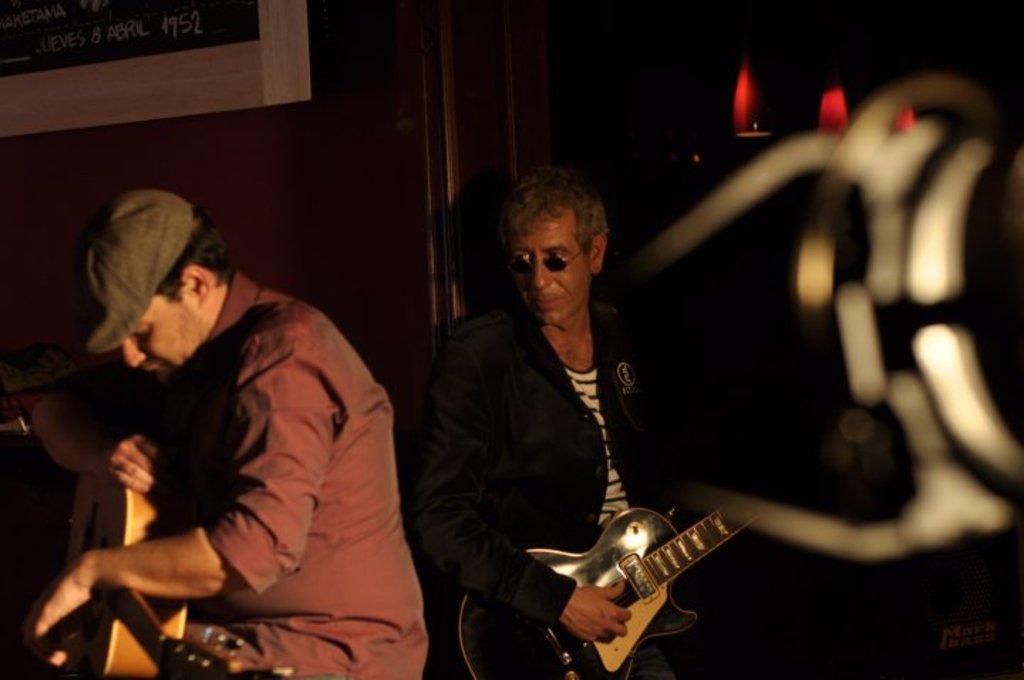How would you summarize this image in a sentence or two? In this image we have two persons who are playing a guitar. The person on the left side is wearing a red t-shirt and a hat. And the person on the right side is wearing a black suit and glasses. 